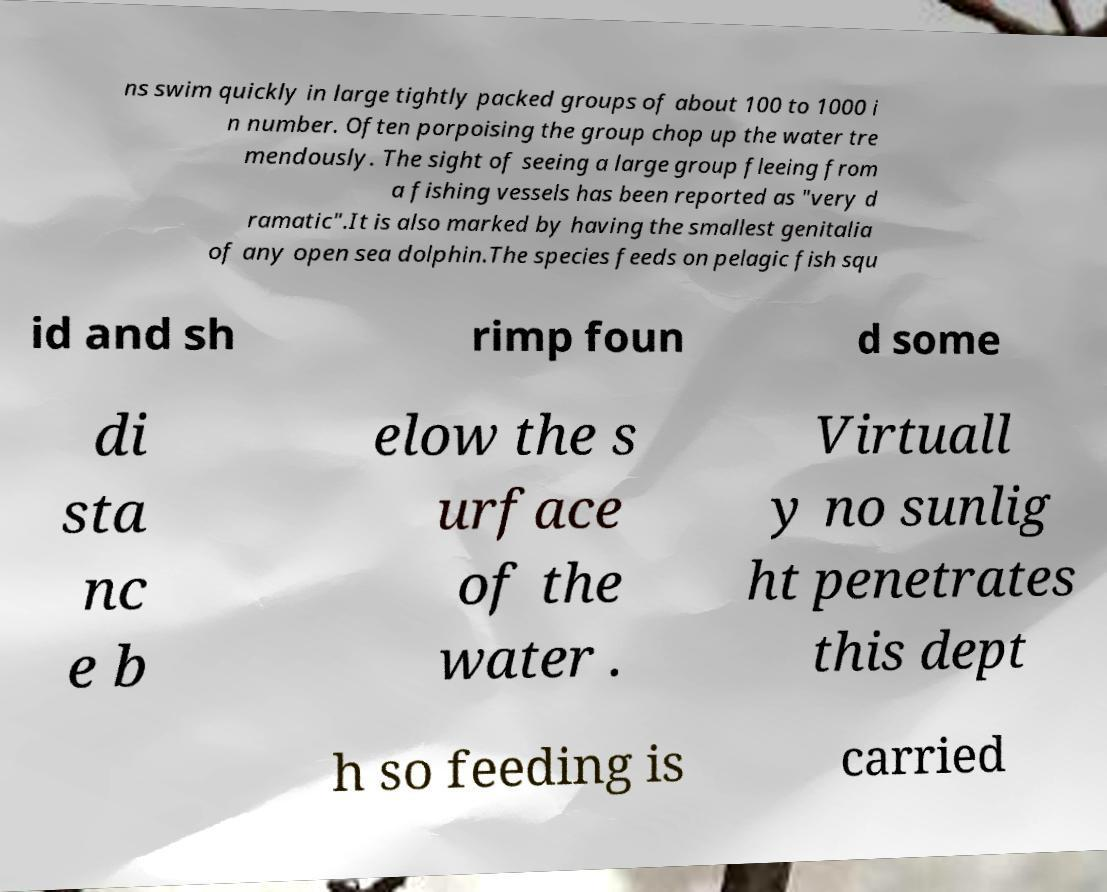Can you read and provide the text displayed in the image?This photo seems to have some interesting text. Can you extract and type it out for me? ns swim quickly in large tightly packed groups of about 100 to 1000 i n number. Often porpoising the group chop up the water tre mendously. The sight of seeing a large group fleeing from a fishing vessels has been reported as "very d ramatic".It is also marked by having the smallest genitalia of any open sea dolphin.The species feeds on pelagic fish squ id and sh rimp foun d some di sta nc e b elow the s urface of the water . Virtuall y no sunlig ht penetrates this dept h so feeding is carried 